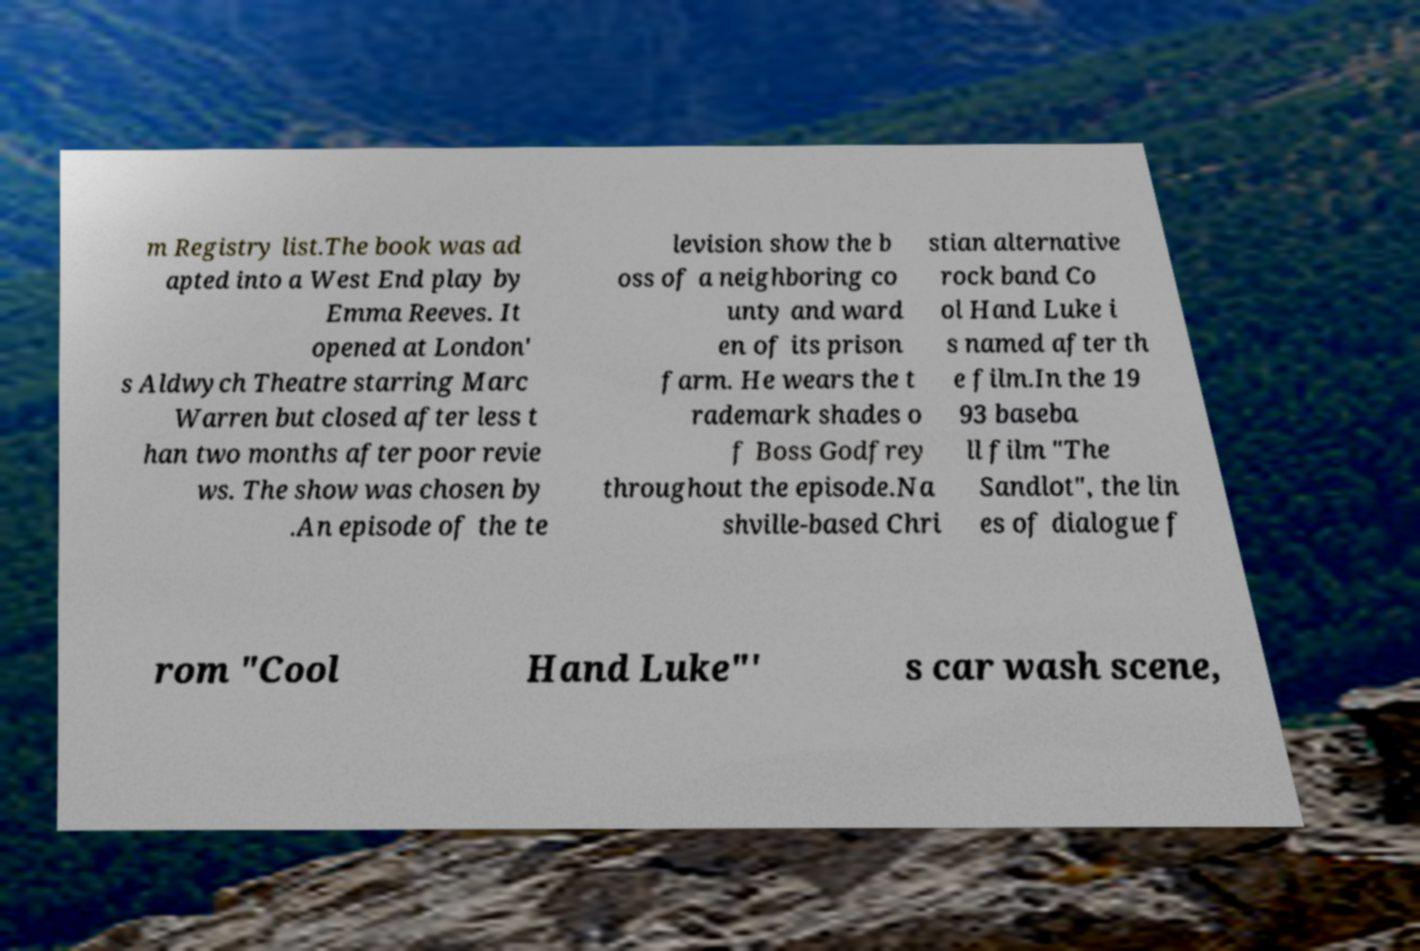Please read and relay the text visible in this image. What does it say? m Registry list.The book was ad apted into a West End play by Emma Reeves. It opened at London' s Aldwych Theatre starring Marc Warren but closed after less t han two months after poor revie ws. The show was chosen by .An episode of the te levision show the b oss of a neighboring co unty and ward en of its prison farm. He wears the t rademark shades o f Boss Godfrey throughout the episode.Na shville-based Chri stian alternative rock band Co ol Hand Luke i s named after th e film.In the 19 93 baseba ll film "The Sandlot", the lin es of dialogue f rom "Cool Hand Luke"' s car wash scene, 